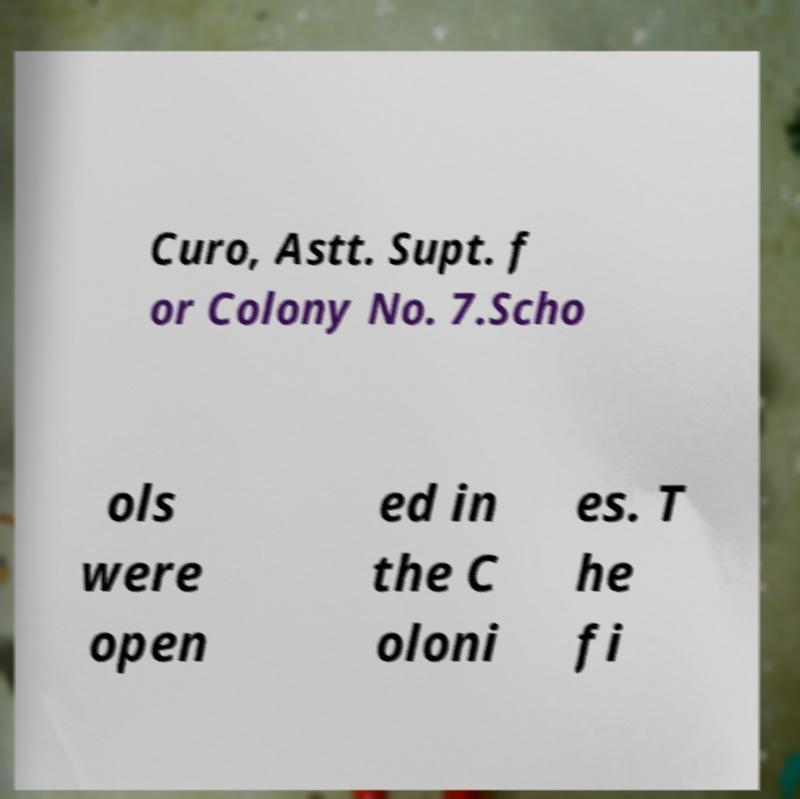I need the written content from this picture converted into text. Can you do that? Curo, Astt. Supt. f or Colony No. 7.Scho ols were open ed in the C oloni es. T he fi 